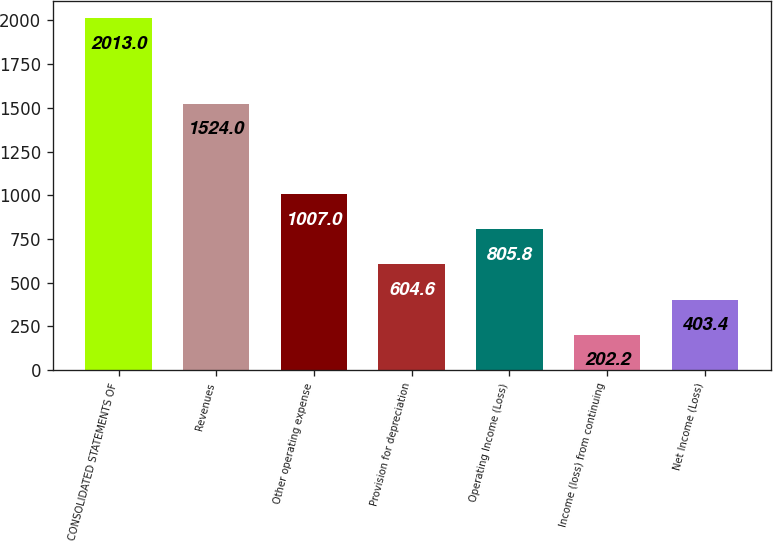Convert chart. <chart><loc_0><loc_0><loc_500><loc_500><bar_chart><fcel>CONSOLIDATED STATEMENTS OF<fcel>Revenues<fcel>Other operating expense<fcel>Provision for depreciation<fcel>Operating Income (Loss)<fcel>Income (loss) from continuing<fcel>Net Income (Loss)<nl><fcel>2013<fcel>1524<fcel>1007<fcel>604.6<fcel>805.8<fcel>202.2<fcel>403.4<nl></chart> 